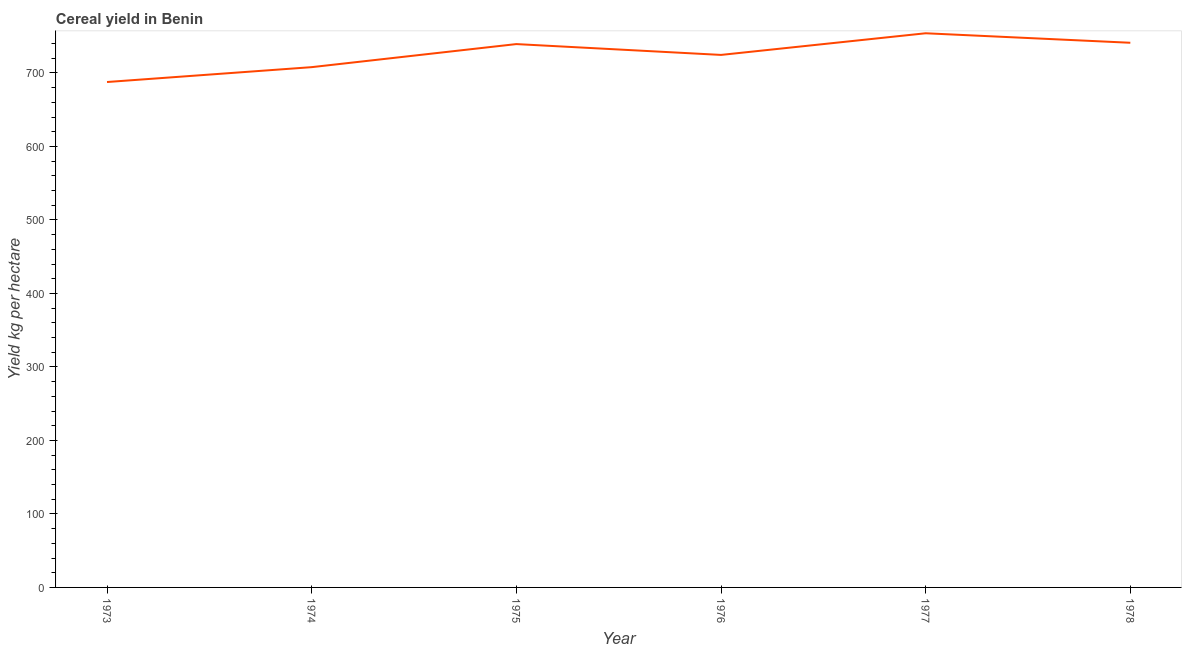What is the cereal yield in 1976?
Provide a short and direct response. 724.56. Across all years, what is the maximum cereal yield?
Offer a terse response. 754.02. Across all years, what is the minimum cereal yield?
Your response must be concise. 687.69. In which year was the cereal yield maximum?
Offer a terse response. 1977. In which year was the cereal yield minimum?
Ensure brevity in your answer.  1973. What is the sum of the cereal yield?
Provide a succinct answer. 4354.57. What is the difference between the cereal yield in 1975 and 1977?
Ensure brevity in your answer.  -14.73. What is the average cereal yield per year?
Provide a short and direct response. 725.76. What is the median cereal yield?
Offer a terse response. 731.93. Do a majority of the years between 1977 and 1976 (inclusive) have cereal yield greater than 420 kg per hectare?
Make the answer very short. No. What is the ratio of the cereal yield in 1973 to that in 1975?
Your answer should be compact. 0.93. Is the cereal yield in 1977 less than that in 1978?
Your response must be concise. No. What is the difference between the highest and the second highest cereal yield?
Your answer should be very brief. 12.94. What is the difference between the highest and the lowest cereal yield?
Your answer should be compact. 66.34. How many years are there in the graph?
Offer a terse response. 6. What is the difference between two consecutive major ticks on the Y-axis?
Give a very brief answer. 100. Are the values on the major ticks of Y-axis written in scientific E-notation?
Ensure brevity in your answer.  No. What is the title of the graph?
Offer a terse response. Cereal yield in Benin. What is the label or title of the Y-axis?
Provide a short and direct response. Yield kg per hectare. What is the Yield kg per hectare of 1973?
Your answer should be compact. 687.69. What is the Yield kg per hectare of 1974?
Ensure brevity in your answer.  707.92. What is the Yield kg per hectare of 1975?
Keep it short and to the point. 739.29. What is the Yield kg per hectare in 1976?
Provide a succinct answer. 724.56. What is the Yield kg per hectare in 1977?
Keep it short and to the point. 754.02. What is the Yield kg per hectare in 1978?
Make the answer very short. 741.08. What is the difference between the Yield kg per hectare in 1973 and 1974?
Your answer should be compact. -20.23. What is the difference between the Yield kg per hectare in 1973 and 1975?
Give a very brief answer. -51.61. What is the difference between the Yield kg per hectare in 1973 and 1976?
Your answer should be very brief. -36.88. What is the difference between the Yield kg per hectare in 1973 and 1977?
Your response must be concise. -66.34. What is the difference between the Yield kg per hectare in 1973 and 1978?
Give a very brief answer. -53.4. What is the difference between the Yield kg per hectare in 1974 and 1975?
Keep it short and to the point. -31.38. What is the difference between the Yield kg per hectare in 1974 and 1976?
Ensure brevity in your answer.  -16.64. What is the difference between the Yield kg per hectare in 1974 and 1977?
Your answer should be compact. -46.1. What is the difference between the Yield kg per hectare in 1974 and 1978?
Give a very brief answer. -33.16. What is the difference between the Yield kg per hectare in 1975 and 1976?
Ensure brevity in your answer.  14.73. What is the difference between the Yield kg per hectare in 1975 and 1977?
Give a very brief answer. -14.73. What is the difference between the Yield kg per hectare in 1975 and 1978?
Provide a succinct answer. -1.79. What is the difference between the Yield kg per hectare in 1976 and 1977?
Offer a very short reply. -29.46. What is the difference between the Yield kg per hectare in 1976 and 1978?
Your answer should be very brief. -16.52. What is the difference between the Yield kg per hectare in 1977 and 1978?
Provide a short and direct response. 12.94. What is the ratio of the Yield kg per hectare in 1973 to that in 1974?
Your response must be concise. 0.97. What is the ratio of the Yield kg per hectare in 1973 to that in 1975?
Offer a terse response. 0.93. What is the ratio of the Yield kg per hectare in 1973 to that in 1976?
Your answer should be compact. 0.95. What is the ratio of the Yield kg per hectare in 1973 to that in 1977?
Your answer should be compact. 0.91. What is the ratio of the Yield kg per hectare in 1973 to that in 1978?
Offer a terse response. 0.93. What is the ratio of the Yield kg per hectare in 1974 to that in 1975?
Give a very brief answer. 0.96. What is the ratio of the Yield kg per hectare in 1974 to that in 1976?
Ensure brevity in your answer.  0.98. What is the ratio of the Yield kg per hectare in 1974 to that in 1977?
Your answer should be compact. 0.94. What is the ratio of the Yield kg per hectare in 1974 to that in 1978?
Offer a terse response. 0.95. What is the ratio of the Yield kg per hectare in 1975 to that in 1977?
Make the answer very short. 0.98. What is the ratio of the Yield kg per hectare in 1976 to that in 1977?
Give a very brief answer. 0.96. What is the ratio of the Yield kg per hectare in 1977 to that in 1978?
Make the answer very short. 1.02. 